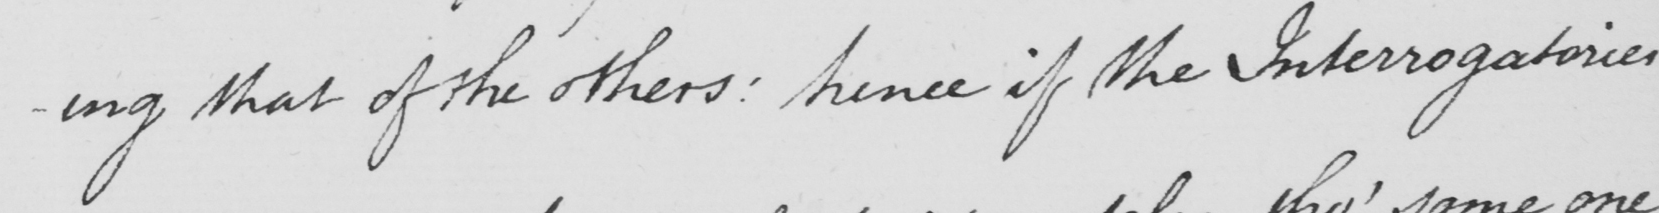Can you read and transcribe this handwriting? that of the others: hence if the Interrogatories 